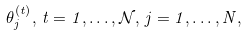<formula> <loc_0><loc_0><loc_500><loc_500>\theta ^ { ( t ) } _ { j } , \, t = 1 , \dots , \mathcal { N } , \, j = 1 , \dots , N ,</formula> 